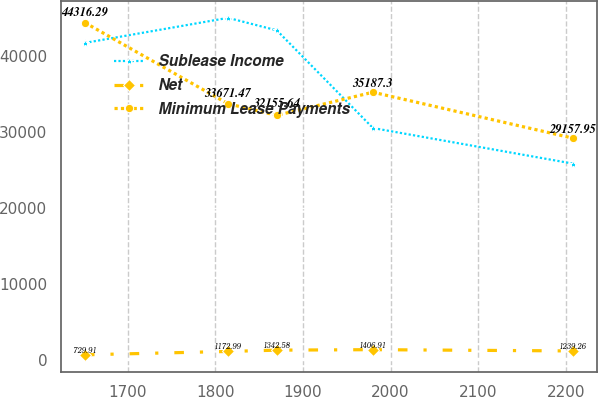Convert chart. <chart><loc_0><loc_0><loc_500><loc_500><line_chart><ecel><fcel>Sublease Income<fcel>Net<fcel>Minimum Lease Payments<nl><fcel>1651.18<fcel>41660.4<fcel>729.91<fcel>44316.3<nl><fcel>1814.51<fcel>44946.4<fcel>1172.99<fcel>33671.5<nl><fcel>1870.21<fcel>43303.4<fcel>1342.58<fcel>32155.6<nl><fcel>1979.89<fcel>30490.7<fcel>1406.91<fcel>35187.3<nl><fcel>2208.17<fcel>25818.5<fcel>1239.26<fcel>29158<nl></chart> 